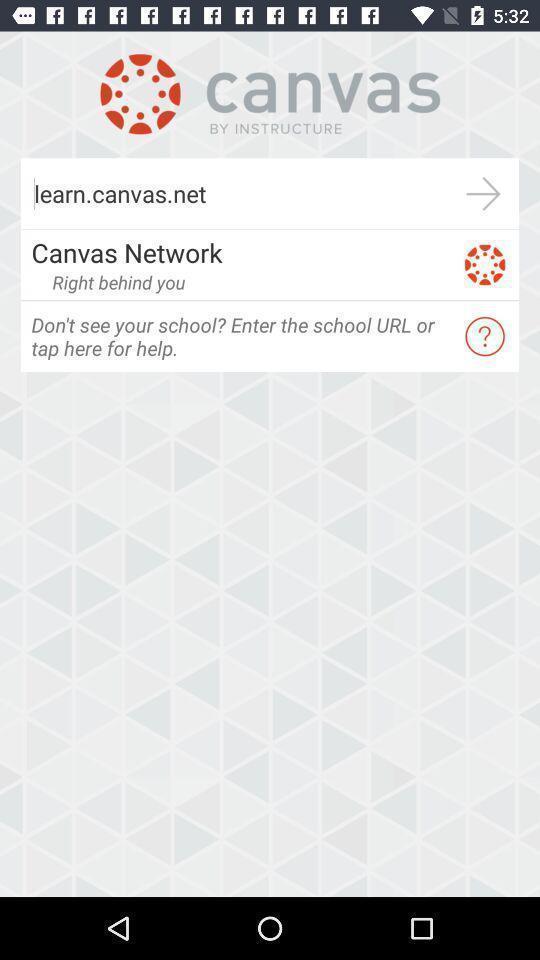Describe this image in words. Welcome page of a learning app. 